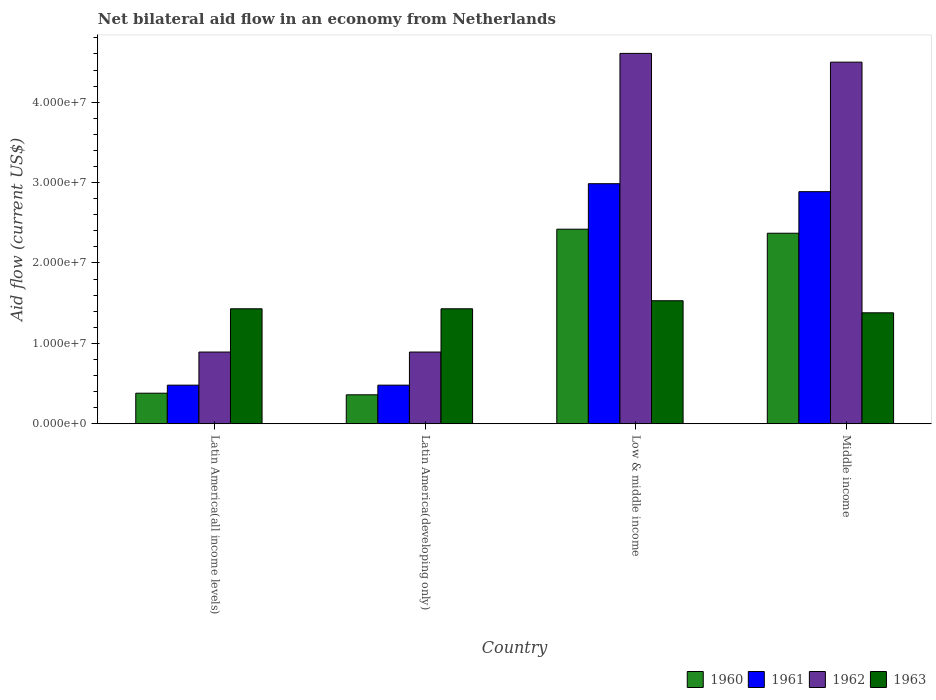How many groups of bars are there?
Offer a terse response. 4. Are the number of bars per tick equal to the number of legend labels?
Provide a short and direct response. Yes. Are the number of bars on each tick of the X-axis equal?
Offer a very short reply. Yes. How many bars are there on the 3rd tick from the left?
Your response must be concise. 4. How many bars are there on the 4th tick from the right?
Your response must be concise. 4. What is the label of the 4th group of bars from the left?
Your response must be concise. Middle income. What is the net bilateral aid flow in 1963 in Middle income?
Offer a terse response. 1.38e+07. Across all countries, what is the maximum net bilateral aid flow in 1962?
Give a very brief answer. 4.61e+07. Across all countries, what is the minimum net bilateral aid flow in 1962?
Give a very brief answer. 8.92e+06. In which country was the net bilateral aid flow in 1960 maximum?
Offer a terse response. Low & middle income. In which country was the net bilateral aid flow in 1960 minimum?
Your answer should be very brief. Latin America(developing only). What is the total net bilateral aid flow in 1962 in the graph?
Give a very brief answer. 1.09e+08. What is the difference between the net bilateral aid flow in 1963 in Latin America(developing only) and that in Low & middle income?
Keep it short and to the point. -1.00e+06. What is the difference between the net bilateral aid flow in 1961 in Low & middle income and the net bilateral aid flow in 1960 in Middle income?
Offer a very short reply. 6.16e+06. What is the average net bilateral aid flow in 1960 per country?
Offer a terse response. 1.38e+07. What is the difference between the net bilateral aid flow of/in 1962 and net bilateral aid flow of/in 1961 in Low & middle income?
Provide a succinct answer. 1.62e+07. What is the ratio of the net bilateral aid flow in 1963 in Latin America(developing only) to that in Middle income?
Your answer should be very brief. 1.04. Is the net bilateral aid flow in 1960 in Latin America(all income levels) less than that in Low & middle income?
Your response must be concise. Yes. Is the difference between the net bilateral aid flow in 1962 in Latin America(developing only) and Low & middle income greater than the difference between the net bilateral aid flow in 1961 in Latin America(developing only) and Low & middle income?
Offer a terse response. No. What is the difference between the highest and the lowest net bilateral aid flow in 1960?
Keep it short and to the point. 2.06e+07. In how many countries, is the net bilateral aid flow in 1960 greater than the average net bilateral aid flow in 1960 taken over all countries?
Provide a short and direct response. 2. Is the sum of the net bilateral aid flow in 1961 in Low & middle income and Middle income greater than the maximum net bilateral aid flow in 1960 across all countries?
Make the answer very short. Yes. Are all the bars in the graph horizontal?
Keep it short and to the point. No. Are the values on the major ticks of Y-axis written in scientific E-notation?
Provide a succinct answer. Yes. Does the graph contain grids?
Keep it short and to the point. No. What is the title of the graph?
Offer a terse response. Net bilateral aid flow in an economy from Netherlands. What is the label or title of the Y-axis?
Make the answer very short. Aid flow (current US$). What is the Aid flow (current US$) in 1960 in Latin America(all income levels)?
Offer a very short reply. 3.80e+06. What is the Aid flow (current US$) in 1961 in Latin America(all income levels)?
Provide a short and direct response. 4.80e+06. What is the Aid flow (current US$) in 1962 in Latin America(all income levels)?
Your answer should be very brief. 8.92e+06. What is the Aid flow (current US$) in 1963 in Latin America(all income levels)?
Provide a succinct answer. 1.43e+07. What is the Aid flow (current US$) of 1960 in Latin America(developing only)?
Offer a very short reply. 3.60e+06. What is the Aid flow (current US$) in 1961 in Latin America(developing only)?
Your answer should be compact. 4.80e+06. What is the Aid flow (current US$) of 1962 in Latin America(developing only)?
Provide a succinct answer. 8.92e+06. What is the Aid flow (current US$) in 1963 in Latin America(developing only)?
Offer a very short reply. 1.43e+07. What is the Aid flow (current US$) of 1960 in Low & middle income?
Your answer should be compact. 2.42e+07. What is the Aid flow (current US$) in 1961 in Low & middle income?
Your response must be concise. 2.99e+07. What is the Aid flow (current US$) in 1962 in Low & middle income?
Offer a terse response. 4.61e+07. What is the Aid flow (current US$) of 1963 in Low & middle income?
Provide a short and direct response. 1.53e+07. What is the Aid flow (current US$) in 1960 in Middle income?
Provide a succinct answer. 2.37e+07. What is the Aid flow (current US$) in 1961 in Middle income?
Give a very brief answer. 2.89e+07. What is the Aid flow (current US$) in 1962 in Middle income?
Offer a terse response. 4.50e+07. What is the Aid flow (current US$) of 1963 in Middle income?
Your answer should be compact. 1.38e+07. Across all countries, what is the maximum Aid flow (current US$) in 1960?
Provide a short and direct response. 2.42e+07. Across all countries, what is the maximum Aid flow (current US$) of 1961?
Your answer should be very brief. 2.99e+07. Across all countries, what is the maximum Aid flow (current US$) of 1962?
Make the answer very short. 4.61e+07. Across all countries, what is the maximum Aid flow (current US$) in 1963?
Provide a short and direct response. 1.53e+07. Across all countries, what is the minimum Aid flow (current US$) in 1960?
Provide a succinct answer. 3.60e+06. Across all countries, what is the minimum Aid flow (current US$) in 1961?
Provide a succinct answer. 4.80e+06. Across all countries, what is the minimum Aid flow (current US$) in 1962?
Ensure brevity in your answer.  8.92e+06. Across all countries, what is the minimum Aid flow (current US$) of 1963?
Your answer should be compact. 1.38e+07. What is the total Aid flow (current US$) in 1960 in the graph?
Your answer should be compact. 5.53e+07. What is the total Aid flow (current US$) of 1961 in the graph?
Your response must be concise. 6.83e+07. What is the total Aid flow (current US$) of 1962 in the graph?
Ensure brevity in your answer.  1.09e+08. What is the total Aid flow (current US$) of 1963 in the graph?
Offer a terse response. 5.77e+07. What is the difference between the Aid flow (current US$) of 1960 in Latin America(all income levels) and that in Latin America(developing only)?
Provide a short and direct response. 2.00e+05. What is the difference between the Aid flow (current US$) in 1962 in Latin America(all income levels) and that in Latin America(developing only)?
Your response must be concise. 0. What is the difference between the Aid flow (current US$) of 1963 in Latin America(all income levels) and that in Latin America(developing only)?
Ensure brevity in your answer.  0. What is the difference between the Aid flow (current US$) of 1960 in Latin America(all income levels) and that in Low & middle income?
Provide a succinct answer. -2.04e+07. What is the difference between the Aid flow (current US$) in 1961 in Latin America(all income levels) and that in Low & middle income?
Provide a short and direct response. -2.51e+07. What is the difference between the Aid flow (current US$) in 1962 in Latin America(all income levels) and that in Low & middle income?
Your answer should be compact. -3.72e+07. What is the difference between the Aid flow (current US$) of 1960 in Latin America(all income levels) and that in Middle income?
Give a very brief answer. -1.99e+07. What is the difference between the Aid flow (current US$) in 1961 in Latin America(all income levels) and that in Middle income?
Give a very brief answer. -2.41e+07. What is the difference between the Aid flow (current US$) in 1962 in Latin America(all income levels) and that in Middle income?
Provide a short and direct response. -3.61e+07. What is the difference between the Aid flow (current US$) of 1960 in Latin America(developing only) and that in Low & middle income?
Offer a terse response. -2.06e+07. What is the difference between the Aid flow (current US$) in 1961 in Latin America(developing only) and that in Low & middle income?
Your answer should be very brief. -2.51e+07. What is the difference between the Aid flow (current US$) of 1962 in Latin America(developing only) and that in Low & middle income?
Make the answer very short. -3.72e+07. What is the difference between the Aid flow (current US$) in 1960 in Latin America(developing only) and that in Middle income?
Make the answer very short. -2.01e+07. What is the difference between the Aid flow (current US$) of 1961 in Latin America(developing only) and that in Middle income?
Your response must be concise. -2.41e+07. What is the difference between the Aid flow (current US$) of 1962 in Latin America(developing only) and that in Middle income?
Provide a succinct answer. -3.61e+07. What is the difference between the Aid flow (current US$) in 1961 in Low & middle income and that in Middle income?
Offer a terse response. 9.90e+05. What is the difference between the Aid flow (current US$) of 1962 in Low & middle income and that in Middle income?
Your response must be concise. 1.09e+06. What is the difference between the Aid flow (current US$) of 1963 in Low & middle income and that in Middle income?
Make the answer very short. 1.50e+06. What is the difference between the Aid flow (current US$) in 1960 in Latin America(all income levels) and the Aid flow (current US$) in 1962 in Latin America(developing only)?
Provide a succinct answer. -5.12e+06. What is the difference between the Aid flow (current US$) of 1960 in Latin America(all income levels) and the Aid flow (current US$) of 1963 in Latin America(developing only)?
Keep it short and to the point. -1.05e+07. What is the difference between the Aid flow (current US$) of 1961 in Latin America(all income levels) and the Aid flow (current US$) of 1962 in Latin America(developing only)?
Provide a succinct answer. -4.12e+06. What is the difference between the Aid flow (current US$) of 1961 in Latin America(all income levels) and the Aid flow (current US$) of 1963 in Latin America(developing only)?
Offer a terse response. -9.50e+06. What is the difference between the Aid flow (current US$) in 1962 in Latin America(all income levels) and the Aid flow (current US$) in 1963 in Latin America(developing only)?
Ensure brevity in your answer.  -5.38e+06. What is the difference between the Aid flow (current US$) in 1960 in Latin America(all income levels) and the Aid flow (current US$) in 1961 in Low & middle income?
Give a very brief answer. -2.61e+07. What is the difference between the Aid flow (current US$) of 1960 in Latin America(all income levels) and the Aid flow (current US$) of 1962 in Low & middle income?
Provide a short and direct response. -4.23e+07. What is the difference between the Aid flow (current US$) of 1960 in Latin America(all income levels) and the Aid flow (current US$) of 1963 in Low & middle income?
Give a very brief answer. -1.15e+07. What is the difference between the Aid flow (current US$) in 1961 in Latin America(all income levels) and the Aid flow (current US$) in 1962 in Low & middle income?
Offer a very short reply. -4.13e+07. What is the difference between the Aid flow (current US$) in 1961 in Latin America(all income levels) and the Aid flow (current US$) in 1963 in Low & middle income?
Your answer should be compact. -1.05e+07. What is the difference between the Aid flow (current US$) in 1962 in Latin America(all income levels) and the Aid flow (current US$) in 1963 in Low & middle income?
Your answer should be compact. -6.38e+06. What is the difference between the Aid flow (current US$) in 1960 in Latin America(all income levels) and the Aid flow (current US$) in 1961 in Middle income?
Your answer should be very brief. -2.51e+07. What is the difference between the Aid flow (current US$) in 1960 in Latin America(all income levels) and the Aid flow (current US$) in 1962 in Middle income?
Your answer should be compact. -4.12e+07. What is the difference between the Aid flow (current US$) of 1960 in Latin America(all income levels) and the Aid flow (current US$) of 1963 in Middle income?
Your answer should be compact. -1.00e+07. What is the difference between the Aid flow (current US$) of 1961 in Latin America(all income levels) and the Aid flow (current US$) of 1962 in Middle income?
Ensure brevity in your answer.  -4.02e+07. What is the difference between the Aid flow (current US$) in 1961 in Latin America(all income levels) and the Aid flow (current US$) in 1963 in Middle income?
Ensure brevity in your answer.  -9.00e+06. What is the difference between the Aid flow (current US$) in 1962 in Latin America(all income levels) and the Aid flow (current US$) in 1963 in Middle income?
Provide a short and direct response. -4.88e+06. What is the difference between the Aid flow (current US$) of 1960 in Latin America(developing only) and the Aid flow (current US$) of 1961 in Low & middle income?
Provide a succinct answer. -2.63e+07. What is the difference between the Aid flow (current US$) in 1960 in Latin America(developing only) and the Aid flow (current US$) in 1962 in Low & middle income?
Provide a short and direct response. -4.25e+07. What is the difference between the Aid flow (current US$) of 1960 in Latin America(developing only) and the Aid flow (current US$) of 1963 in Low & middle income?
Keep it short and to the point. -1.17e+07. What is the difference between the Aid flow (current US$) in 1961 in Latin America(developing only) and the Aid flow (current US$) in 1962 in Low & middle income?
Provide a short and direct response. -4.13e+07. What is the difference between the Aid flow (current US$) in 1961 in Latin America(developing only) and the Aid flow (current US$) in 1963 in Low & middle income?
Give a very brief answer. -1.05e+07. What is the difference between the Aid flow (current US$) in 1962 in Latin America(developing only) and the Aid flow (current US$) in 1963 in Low & middle income?
Give a very brief answer. -6.38e+06. What is the difference between the Aid flow (current US$) in 1960 in Latin America(developing only) and the Aid flow (current US$) in 1961 in Middle income?
Provide a short and direct response. -2.53e+07. What is the difference between the Aid flow (current US$) in 1960 in Latin America(developing only) and the Aid flow (current US$) in 1962 in Middle income?
Ensure brevity in your answer.  -4.14e+07. What is the difference between the Aid flow (current US$) of 1960 in Latin America(developing only) and the Aid flow (current US$) of 1963 in Middle income?
Give a very brief answer. -1.02e+07. What is the difference between the Aid flow (current US$) in 1961 in Latin America(developing only) and the Aid flow (current US$) in 1962 in Middle income?
Ensure brevity in your answer.  -4.02e+07. What is the difference between the Aid flow (current US$) in 1961 in Latin America(developing only) and the Aid flow (current US$) in 1963 in Middle income?
Your answer should be very brief. -9.00e+06. What is the difference between the Aid flow (current US$) of 1962 in Latin America(developing only) and the Aid flow (current US$) of 1963 in Middle income?
Your response must be concise. -4.88e+06. What is the difference between the Aid flow (current US$) in 1960 in Low & middle income and the Aid flow (current US$) in 1961 in Middle income?
Your response must be concise. -4.67e+06. What is the difference between the Aid flow (current US$) of 1960 in Low & middle income and the Aid flow (current US$) of 1962 in Middle income?
Make the answer very short. -2.08e+07. What is the difference between the Aid flow (current US$) in 1960 in Low & middle income and the Aid flow (current US$) in 1963 in Middle income?
Provide a short and direct response. 1.04e+07. What is the difference between the Aid flow (current US$) in 1961 in Low & middle income and the Aid flow (current US$) in 1962 in Middle income?
Your answer should be very brief. -1.51e+07. What is the difference between the Aid flow (current US$) in 1961 in Low & middle income and the Aid flow (current US$) in 1963 in Middle income?
Your response must be concise. 1.61e+07. What is the difference between the Aid flow (current US$) in 1962 in Low & middle income and the Aid flow (current US$) in 1963 in Middle income?
Offer a terse response. 3.23e+07. What is the average Aid flow (current US$) in 1960 per country?
Offer a terse response. 1.38e+07. What is the average Aid flow (current US$) in 1961 per country?
Provide a short and direct response. 1.71e+07. What is the average Aid flow (current US$) of 1962 per country?
Your answer should be very brief. 2.72e+07. What is the average Aid flow (current US$) of 1963 per country?
Offer a terse response. 1.44e+07. What is the difference between the Aid flow (current US$) of 1960 and Aid flow (current US$) of 1962 in Latin America(all income levels)?
Offer a terse response. -5.12e+06. What is the difference between the Aid flow (current US$) in 1960 and Aid flow (current US$) in 1963 in Latin America(all income levels)?
Your answer should be very brief. -1.05e+07. What is the difference between the Aid flow (current US$) in 1961 and Aid flow (current US$) in 1962 in Latin America(all income levels)?
Offer a very short reply. -4.12e+06. What is the difference between the Aid flow (current US$) in 1961 and Aid flow (current US$) in 1963 in Latin America(all income levels)?
Your response must be concise. -9.50e+06. What is the difference between the Aid flow (current US$) of 1962 and Aid flow (current US$) of 1963 in Latin America(all income levels)?
Give a very brief answer. -5.38e+06. What is the difference between the Aid flow (current US$) in 1960 and Aid flow (current US$) in 1961 in Latin America(developing only)?
Your answer should be very brief. -1.20e+06. What is the difference between the Aid flow (current US$) of 1960 and Aid flow (current US$) of 1962 in Latin America(developing only)?
Give a very brief answer. -5.32e+06. What is the difference between the Aid flow (current US$) in 1960 and Aid flow (current US$) in 1963 in Latin America(developing only)?
Your answer should be compact. -1.07e+07. What is the difference between the Aid flow (current US$) in 1961 and Aid flow (current US$) in 1962 in Latin America(developing only)?
Offer a terse response. -4.12e+06. What is the difference between the Aid flow (current US$) in 1961 and Aid flow (current US$) in 1963 in Latin America(developing only)?
Keep it short and to the point. -9.50e+06. What is the difference between the Aid flow (current US$) of 1962 and Aid flow (current US$) of 1963 in Latin America(developing only)?
Your answer should be compact. -5.38e+06. What is the difference between the Aid flow (current US$) of 1960 and Aid flow (current US$) of 1961 in Low & middle income?
Give a very brief answer. -5.66e+06. What is the difference between the Aid flow (current US$) of 1960 and Aid flow (current US$) of 1962 in Low & middle income?
Provide a short and direct response. -2.19e+07. What is the difference between the Aid flow (current US$) of 1960 and Aid flow (current US$) of 1963 in Low & middle income?
Make the answer very short. 8.90e+06. What is the difference between the Aid flow (current US$) in 1961 and Aid flow (current US$) in 1962 in Low & middle income?
Offer a very short reply. -1.62e+07. What is the difference between the Aid flow (current US$) of 1961 and Aid flow (current US$) of 1963 in Low & middle income?
Your answer should be compact. 1.46e+07. What is the difference between the Aid flow (current US$) in 1962 and Aid flow (current US$) in 1963 in Low & middle income?
Offer a terse response. 3.08e+07. What is the difference between the Aid flow (current US$) in 1960 and Aid flow (current US$) in 1961 in Middle income?
Provide a short and direct response. -5.17e+06. What is the difference between the Aid flow (current US$) of 1960 and Aid flow (current US$) of 1962 in Middle income?
Your answer should be compact. -2.13e+07. What is the difference between the Aid flow (current US$) of 1960 and Aid flow (current US$) of 1963 in Middle income?
Your answer should be very brief. 9.90e+06. What is the difference between the Aid flow (current US$) of 1961 and Aid flow (current US$) of 1962 in Middle income?
Your answer should be compact. -1.61e+07. What is the difference between the Aid flow (current US$) in 1961 and Aid flow (current US$) in 1963 in Middle income?
Your answer should be very brief. 1.51e+07. What is the difference between the Aid flow (current US$) of 1962 and Aid flow (current US$) of 1963 in Middle income?
Your response must be concise. 3.12e+07. What is the ratio of the Aid flow (current US$) of 1960 in Latin America(all income levels) to that in Latin America(developing only)?
Ensure brevity in your answer.  1.06. What is the ratio of the Aid flow (current US$) of 1962 in Latin America(all income levels) to that in Latin America(developing only)?
Your answer should be compact. 1. What is the ratio of the Aid flow (current US$) of 1960 in Latin America(all income levels) to that in Low & middle income?
Offer a terse response. 0.16. What is the ratio of the Aid flow (current US$) in 1961 in Latin America(all income levels) to that in Low & middle income?
Keep it short and to the point. 0.16. What is the ratio of the Aid flow (current US$) of 1962 in Latin America(all income levels) to that in Low & middle income?
Make the answer very short. 0.19. What is the ratio of the Aid flow (current US$) in 1963 in Latin America(all income levels) to that in Low & middle income?
Make the answer very short. 0.93. What is the ratio of the Aid flow (current US$) in 1960 in Latin America(all income levels) to that in Middle income?
Keep it short and to the point. 0.16. What is the ratio of the Aid flow (current US$) of 1961 in Latin America(all income levels) to that in Middle income?
Provide a succinct answer. 0.17. What is the ratio of the Aid flow (current US$) of 1962 in Latin America(all income levels) to that in Middle income?
Ensure brevity in your answer.  0.2. What is the ratio of the Aid flow (current US$) of 1963 in Latin America(all income levels) to that in Middle income?
Offer a very short reply. 1.04. What is the ratio of the Aid flow (current US$) in 1960 in Latin America(developing only) to that in Low & middle income?
Your response must be concise. 0.15. What is the ratio of the Aid flow (current US$) of 1961 in Latin America(developing only) to that in Low & middle income?
Provide a succinct answer. 0.16. What is the ratio of the Aid flow (current US$) in 1962 in Latin America(developing only) to that in Low & middle income?
Offer a very short reply. 0.19. What is the ratio of the Aid flow (current US$) of 1963 in Latin America(developing only) to that in Low & middle income?
Your response must be concise. 0.93. What is the ratio of the Aid flow (current US$) in 1960 in Latin America(developing only) to that in Middle income?
Keep it short and to the point. 0.15. What is the ratio of the Aid flow (current US$) of 1961 in Latin America(developing only) to that in Middle income?
Your response must be concise. 0.17. What is the ratio of the Aid flow (current US$) of 1962 in Latin America(developing only) to that in Middle income?
Offer a terse response. 0.2. What is the ratio of the Aid flow (current US$) in 1963 in Latin America(developing only) to that in Middle income?
Give a very brief answer. 1.04. What is the ratio of the Aid flow (current US$) in 1960 in Low & middle income to that in Middle income?
Offer a terse response. 1.02. What is the ratio of the Aid flow (current US$) in 1961 in Low & middle income to that in Middle income?
Your response must be concise. 1.03. What is the ratio of the Aid flow (current US$) of 1962 in Low & middle income to that in Middle income?
Keep it short and to the point. 1.02. What is the ratio of the Aid flow (current US$) in 1963 in Low & middle income to that in Middle income?
Keep it short and to the point. 1.11. What is the difference between the highest and the second highest Aid flow (current US$) in 1961?
Ensure brevity in your answer.  9.90e+05. What is the difference between the highest and the second highest Aid flow (current US$) in 1962?
Keep it short and to the point. 1.09e+06. What is the difference between the highest and the second highest Aid flow (current US$) of 1963?
Offer a very short reply. 1.00e+06. What is the difference between the highest and the lowest Aid flow (current US$) in 1960?
Offer a very short reply. 2.06e+07. What is the difference between the highest and the lowest Aid flow (current US$) of 1961?
Make the answer very short. 2.51e+07. What is the difference between the highest and the lowest Aid flow (current US$) of 1962?
Your response must be concise. 3.72e+07. What is the difference between the highest and the lowest Aid flow (current US$) in 1963?
Provide a short and direct response. 1.50e+06. 